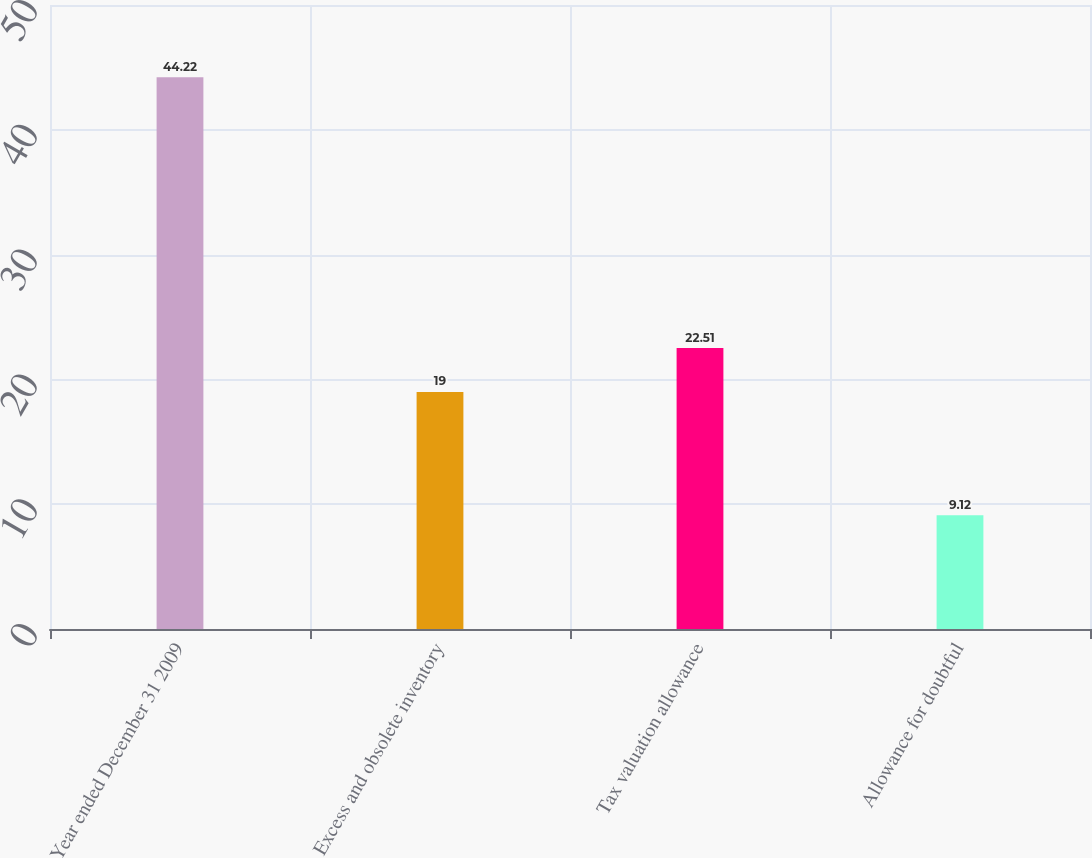Convert chart to OTSL. <chart><loc_0><loc_0><loc_500><loc_500><bar_chart><fcel>Year ended December 31 2009<fcel>Excess and obsolete inventory<fcel>Tax valuation allowance<fcel>Allowance for doubtful<nl><fcel>44.22<fcel>19<fcel>22.51<fcel>9.12<nl></chart> 